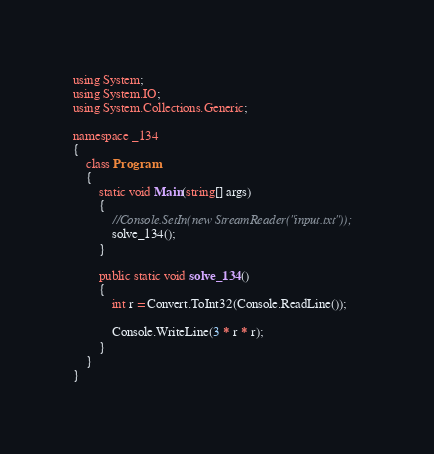<code> <loc_0><loc_0><loc_500><loc_500><_C#_>using System;
using System.IO;
using System.Collections.Generic;

namespace _134
{
    class Program
    {
        static void Main(string[] args)
        {
            //Console.SetIn(new StreamReader("input.txt"));
            solve_134();
        }

        public static void solve_134()
        {
            int r = Convert.ToInt32(Console.ReadLine());

            Console.WriteLine(3 * r * r);
        }
    }
}
</code> 